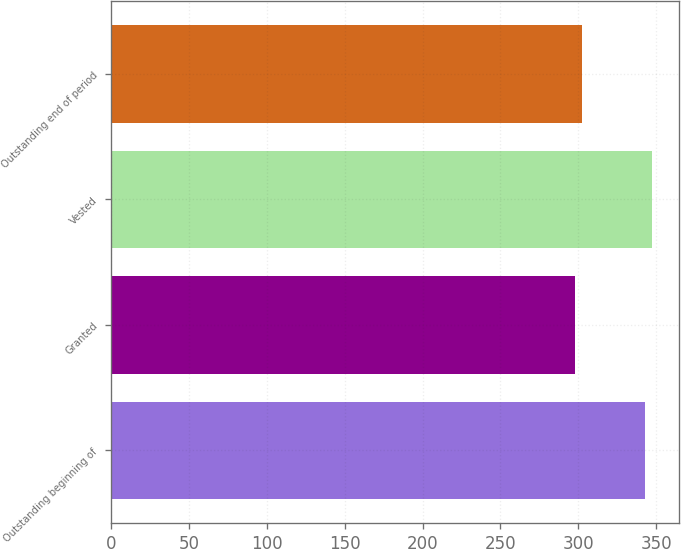Convert chart to OTSL. <chart><loc_0><loc_0><loc_500><loc_500><bar_chart><fcel>Outstanding beginning of<fcel>Granted<fcel>Vested<fcel>Outstanding end of period<nl><fcel>343.1<fcel>297.86<fcel>347.62<fcel>302.38<nl></chart> 